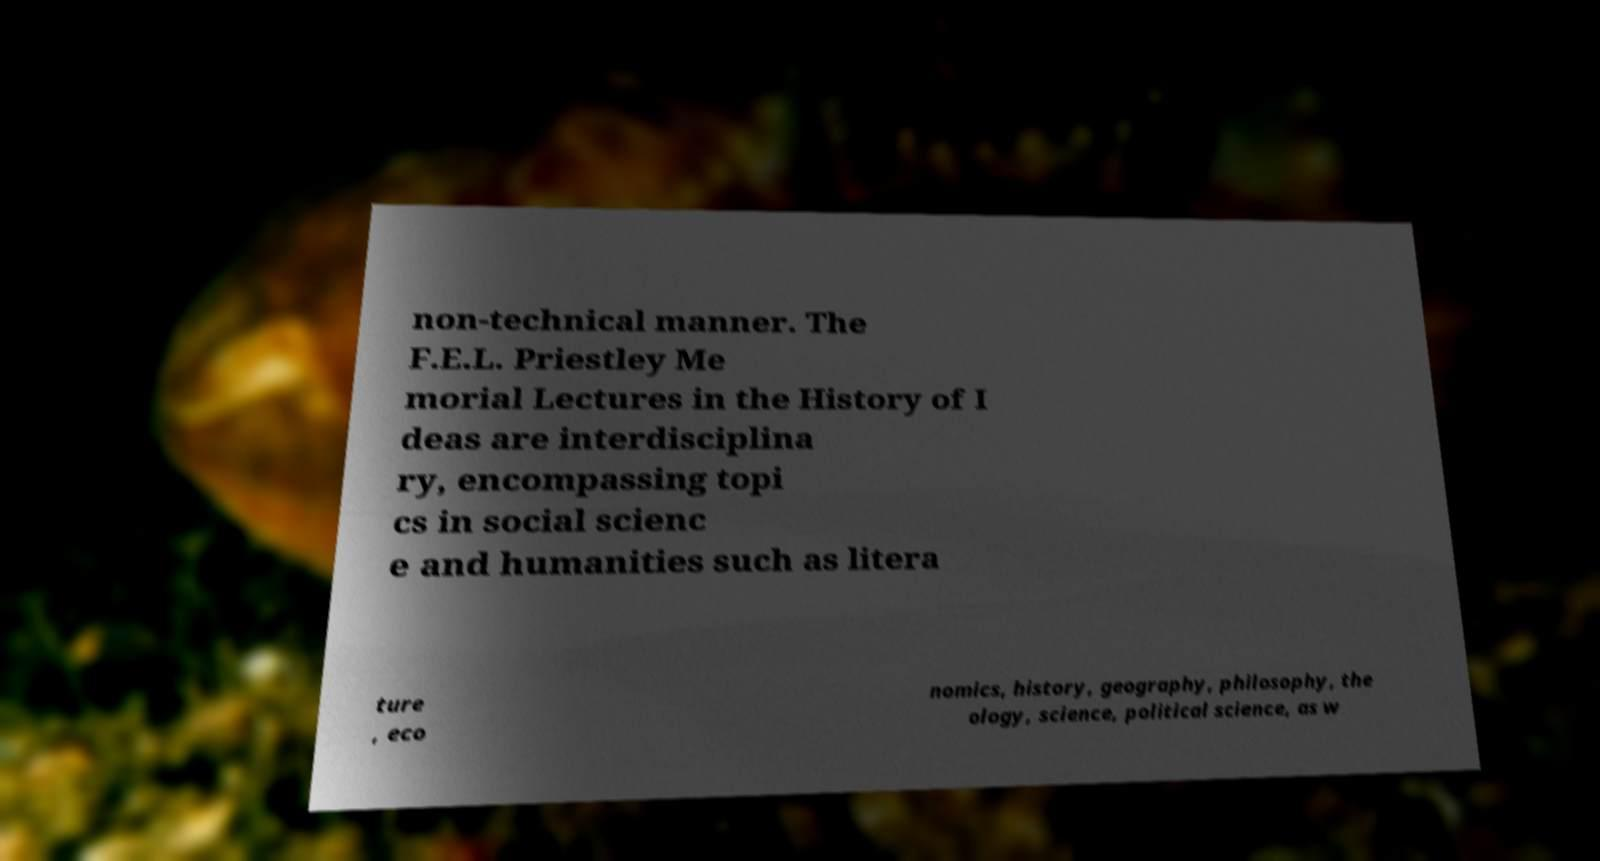I need the written content from this picture converted into text. Can you do that? non-technical manner. The F.E.L. Priestley Me morial Lectures in the History of I deas are interdisciplina ry, encompassing topi cs in social scienc e and humanities such as litera ture , eco nomics, history, geography, philosophy, the ology, science, political science, as w 